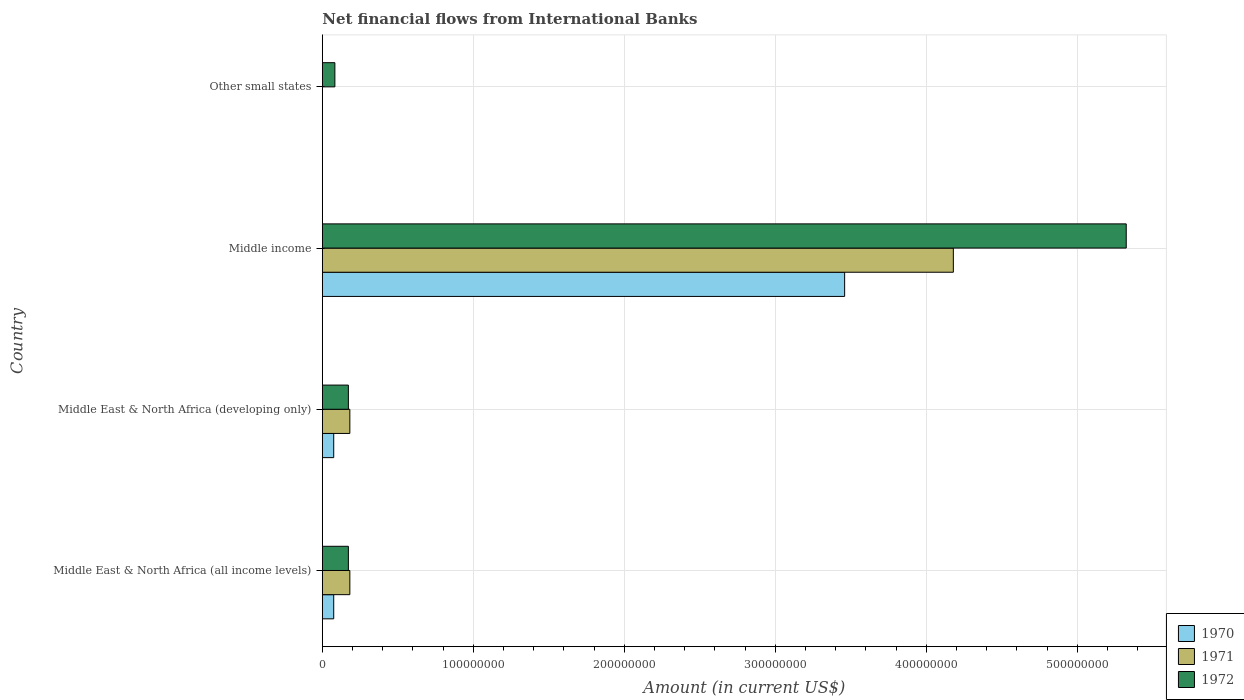Are the number of bars per tick equal to the number of legend labels?
Provide a succinct answer. No. How many bars are there on the 1st tick from the top?
Your response must be concise. 1. What is the label of the 4th group of bars from the top?
Provide a short and direct response. Middle East & North Africa (all income levels). Across all countries, what is the maximum net financial aid flows in 1971?
Your answer should be very brief. 4.18e+08. In which country was the net financial aid flows in 1972 maximum?
Ensure brevity in your answer.  Middle income. What is the total net financial aid flows in 1971 in the graph?
Keep it short and to the point. 4.54e+08. What is the difference between the net financial aid flows in 1972 in Middle East & North Africa (developing only) and that in Other small states?
Your answer should be compact. 8.94e+06. What is the difference between the net financial aid flows in 1972 in Middle income and the net financial aid flows in 1971 in Middle East & North Africa (developing only)?
Give a very brief answer. 5.14e+08. What is the average net financial aid flows in 1971 per country?
Offer a terse response. 1.14e+08. What is the difference between the net financial aid flows in 1970 and net financial aid flows in 1972 in Middle East & North Africa (all income levels)?
Your response must be concise. -9.70e+06. In how many countries, is the net financial aid flows in 1970 greater than 320000000 US$?
Offer a terse response. 1. What is the ratio of the net financial aid flows in 1971 in Middle East & North Africa (all income levels) to that in Middle income?
Your answer should be very brief. 0.04. Is the net financial aid flows in 1972 in Middle East & North Africa (all income levels) less than that in Middle income?
Make the answer very short. Yes. What is the difference between the highest and the second highest net financial aid flows in 1971?
Make the answer very short. 4.00e+08. What is the difference between the highest and the lowest net financial aid flows in 1970?
Make the answer very short. 3.46e+08. Is the sum of the net financial aid flows in 1970 in Middle East & North Africa (all income levels) and Middle income greater than the maximum net financial aid flows in 1972 across all countries?
Keep it short and to the point. No. Is it the case that in every country, the sum of the net financial aid flows in 1971 and net financial aid flows in 1972 is greater than the net financial aid flows in 1970?
Offer a very short reply. Yes. How many bars are there?
Provide a succinct answer. 10. Are all the bars in the graph horizontal?
Keep it short and to the point. Yes. Does the graph contain grids?
Make the answer very short. Yes. How many legend labels are there?
Offer a terse response. 3. How are the legend labels stacked?
Provide a succinct answer. Vertical. What is the title of the graph?
Your answer should be very brief. Net financial flows from International Banks. Does "1970" appear as one of the legend labels in the graph?
Offer a very short reply. Yes. What is the label or title of the X-axis?
Offer a very short reply. Amount (in current US$). What is the Amount (in current US$) of 1970 in Middle East & North Africa (all income levels)?
Ensure brevity in your answer.  7.55e+06. What is the Amount (in current US$) in 1971 in Middle East & North Africa (all income levels)?
Ensure brevity in your answer.  1.82e+07. What is the Amount (in current US$) of 1972 in Middle East & North Africa (all income levels)?
Offer a very short reply. 1.73e+07. What is the Amount (in current US$) in 1970 in Middle East & North Africa (developing only)?
Provide a succinct answer. 7.55e+06. What is the Amount (in current US$) of 1971 in Middle East & North Africa (developing only)?
Offer a very short reply. 1.82e+07. What is the Amount (in current US$) in 1972 in Middle East & North Africa (developing only)?
Make the answer very short. 1.73e+07. What is the Amount (in current US$) of 1970 in Middle income?
Ensure brevity in your answer.  3.46e+08. What is the Amount (in current US$) in 1971 in Middle income?
Provide a succinct answer. 4.18e+08. What is the Amount (in current US$) in 1972 in Middle income?
Offer a very short reply. 5.32e+08. What is the Amount (in current US$) of 1972 in Other small states?
Offer a terse response. 8.31e+06. Across all countries, what is the maximum Amount (in current US$) in 1970?
Give a very brief answer. 3.46e+08. Across all countries, what is the maximum Amount (in current US$) of 1971?
Ensure brevity in your answer.  4.18e+08. Across all countries, what is the maximum Amount (in current US$) of 1972?
Your answer should be very brief. 5.32e+08. Across all countries, what is the minimum Amount (in current US$) in 1970?
Your answer should be very brief. 0. Across all countries, what is the minimum Amount (in current US$) of 1972?
Ensure brevity in your answer.  8.31e+06. What is the total Amount (in current US$) of 1970 in the graph?
Keep it short and to the point. 3.61e+08. What is the total Amount (in current US$) in 1971 in the graph?
Provide a succinct answer. 4.54e+08. What is the total Amount (in current US$) of 1972 in the graph?
Your answer should be very brief. 5.75e+08. What is the difference between the Amount (in current US$) of 1970 in Middle East & North Africa (all income levels) and that in Middle East & North Africa (developing only)?
Your response must be concise. 0. What is the difference between the Amount (in current US$) in 1971 in Middle East & North Africa (all income levels) and that in Middle East & North Africa (developing only)?
Provide a short and direct response. 0. What is the difference between the Amount (in current US$) in 1972 in Middle East & North Africa (all income levels) and that in Middle East & North Africa (developing only)?
Give a very brief answer. 0. What is the difference between the Amount (in current US$) in 1970 in Middle East & North Africa (all income levels) and that in Middle income?
Your answer should be very brief. -3.38e+08. What is the difference between the Amount (in current US$) of 1971 in Middle East & North Africa (all income levels) and that in Middle income?
Provide a short and direct response. -4.00e+08. What is the difference between the Amount (in current US$) in 1972 in Middle East & North Africa (all income levels) and that in Middle income?
Give a very brief answer. -5.15e+08. What is the difference between the Amount (in current US$) of 1972 in Middle East & North Africa (all income levels) and that in Other small states?
Offer a very short reply. 8.94e+06. What is the difference between the Amount (in current US$) in 1970 in Middle East & North Africa (developing only) and that in Middle income?
Keep it short and to the point. -3.38e+08. What is the difference between the Amount (in current US$) of 1971 in Middle East & North Africa (developing only) and that in Middle income?
Offer a terse response. -4.00e+08. What is the difference between the Amount (in current US$) of 1972 in Middle East & North Africa (developing only) and that in Middle income?
Make the answer very short. -5.15e+08. What is the difference between the Amount (in current US$) in 1972 in Middle East & North Africa (developing only) and that in Other small states?
Provide a short and direct response. 8.94e+06. What is the difference between the Amount (in current US$) in 1972 in Middle income and that in Other small states?
Your response must be concise. 5.24e+08. What is the difference between the Amount (in current US$) in 1970 in Middle East & North Africa (all income levels) and the Amount (in current US$) in 1971 in Middle East & North Africa (developing only)?
Offer a terse response. -1.07e+07. What is the difference between the Amount (in current US$) in 1970 in Middle East & North Africa (all income levels) and the Amount (in current US$) in 1972 in Middle East & North Africa (developing only)?
Keep it short and to the point. -9.70e+06. What is the difference between the Amount (in current US$) of 1971 in Middle East & North Africa (all income levels) and the Amount (in current US$) of 1972 in Middle East & North Africa (developing only)?
Offer a very short reply. 9.78e+05. What is the difference between the Amount (in current US$) in 1970 in Middle East & North Africa (all income levels) and the Amount (in current US$) in 1971 in Middle income?
Offer a terse response. -4.10e+08. What is the difference between the Amount (in current US$) of 1970 in Middle East & North Africa (all income levels) and the Amount (in current US$) of 1972 in Middle income?
Offer a terse response. -5.25e+08. What is the difference between the Amount (in current US$) in 1971 in Middle East & North Africa (all income levels) and the Amount (in current US$) in 1972 in Middle income?
Offer a very short reply. -5.14e+08. What is the difference between the Amount (in current US$) of 1970 in Middle East & North Africa (all income levels) and the Amount (in current US$) of 1972 in Other small states?
Your answer should be compact. -7.62e+05. What is the difference between the Amount (in current US$) of 1971 in Middle East & North Africa (all income levels) and the Amount (in current US$) of 1972 in Other small states?
Offer a terse response. 9.92e+06. What is the difference between the Amount (in current US$) in 1970 in Middle East & North Africa (developing only) and the Amount (in current US$) in 1971 in Middle income?
Provide a short and direct response. -4.10e+08. What is the difference between the Amount (in current US$) in 1970 in Middle East & North Africa (developing only) and the Amount (in current US$) in 1972 in Middle income?
Make the answer very short. -5.25e+08. What is the difference between the Amount (in current US$) in 1971 in Middle East & North Africa (developing only) and the Amount (in current US$) in 1972 in Middle income?
Your answer should be very brief. -5.14e+08. What is the difference between the Amount (in current US$) of 1970 in Middle East & North Africa (developing only) and the Amount (in current US$) of 1972 in Other small states?
Your response must be concise. -7.62e+05. What is the difference between the Amount (in current US$) of 1971 in Middle East & North Africa (developing only) and the Amount (in current US$) of 1972 in Other small states?
Give a very brief answer. 9.92e+06. What is the difference between the Amount (in current US$) in 1970 in Middle income and the Amount (in current US$) in 1972 in Other small states?
Provide a succinct answer. 3.38e+08. What is the difference between the Amount (in current US$) in 1971 in Middle income and the Amount (in current US$) in 1972 in Other small states?
Your response must be concise. 4.10e+08. What is the average Amount (in current US$) of 1970 per country?
Ensure brevity in your answer.  9.03e+07. What is the average Amount (in current US$) of 1971 per country?
Keep it short and to the point. 1.14e+08. What is the average Amount (in current US$) in 1972 per country?
Offer a very short reply. 1.44e+08. What is the difference between the Amount (in current US$) in 1970 and Amount (in current US$) in 1971 in Middle East & North Africa (all income levels)?
Offer a terse response. -1.07e+07. What is the difference between the Amount (in current US$) of 1970 and Amount (in current US$) of 1972 in Middle East & North Africa (all income levels)?
Give a very brief answer. -9.70e+06. What is the difference between the Amount (in current US$) of 1971 and Amount (in current US$) of 1972 in Middle East & North Africa (all income levels)?
Provide a short and direct response. 9.78e+05. What is the difference between the Amount (in current US$) in 1970 and Amount (in current US$) in 1971 in Middle East & North Africa (developing only)?
Keep it short and to the point. -1.07e+07. What is the difference between the Amount (in current US$) of 1970 and Amount (in current US$) of 1972 in Middle East & North Africa (developing only)?
Offer a terse response. -9.70e+06. What is the difference between the Amount (in current US$) of 1971 and Amount (in current US$) of 1972 in Middle East & North Africa (developing only)?
Keep it short and to the point. 9.78e+05. What is the difference between the Amount (in current US$) of 1970 and Amount (in current US$) of 1971 in Middle income?
Make the answer very short. -7.20e+07. What is the difference between the Amount (in current US$) in 1970 and Amount (in current US$) in 1972 in Middle income?
Provide a succinct answer. -1.87e+08. What is the difference between the Amount (in current US$) in 1971 and Amount (in current US$) in 1972 in Middle income?
Provide a succinct answer. -1.15e+08. What is the ratio of the Amount (in current US$) in 1971 in Middle East & North Africa (all income levels) to that in Middle East & North Africa (developing only)?
Make the answer very short. 1. What is the ratio of the Amount (in current US$) of 1970 in Middle East & North Africa (all income levels) to that in Middle income?
Keep it short and to the point. 0.02. What is the ratio of the Amount (in current US$) in 1971 in Middle East & North Africa (all income levels) to that in Middle income?
Keep it short and to the point. 0.04. What is the ratio of the Amount (in current US$) of 1972 in Middle East & North Africa (all income levels) to that in Middle income?
Give a very brief answer. 0.03. What is the ratio of the Amount (in current US$) in 1972 in Middle East & North Africa (all income levels) to that in Other small states?
Your response must be concise. 2.08. What is the ratio of the Amount (in current US$) in 1970 in Middle East & North Africa (developing only) to that in Middle income?
Make the answer very short. 0.02. What is the ratio of the Amount (in current US$) in 1971 in Middle East & North Africa (developing only) to that in Middle income?
Offer a very short reply. 0.04. What is the ratio of the Amount (in current US$) of 1972 in Middle East & North Africa (developing only) to that in Middle income?
Keep it short and to the point. 0.03. What is the ratio of the Amount (in current US$) in 1972 in Middle East & North Africa (developing only) to that in Other small states?
Provide a short and direct response. 2.08. What is the ratio of the Amount (in current US$) in 1972 in Middle income to that in Other small states?
Keep it short and to the point. 64.08. What is the difference between the highest and the second highest Amount (in current US$) of 1970?
Your answer should be compact. 3.38e+08. What is the difference between the highest and the second highest Amount (in current US$) in 1971?
Provide a short and direct response. 4.00e+08. What is the difference between the highest and the second highest Amount (in current US$) in 1972?
Ensure brevity in your answer.  5.15e+08. What is the difference between the highest and the lowest Amount (in current US$) in 1970?
Offer a terse response. 3.46e+08. What is the difference between the highest and the lowest Amount (in current US$) of 1971?
Your response must be concise. 4.18e+08. What is the difference between the highest and the lowest Amount (in current US$) of 1972?
Offer a terse response. 5.24e+08. 